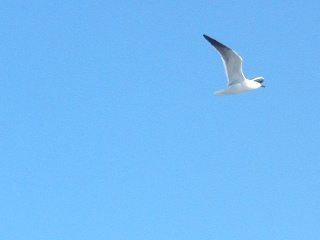Describe the setting of this image. The image showcases a serene, cloudless sky with a single bird, possibly a seagull, gliding gracefully. The bright blue backdrop emphasizes the bird's elegance as it soars through the air. 